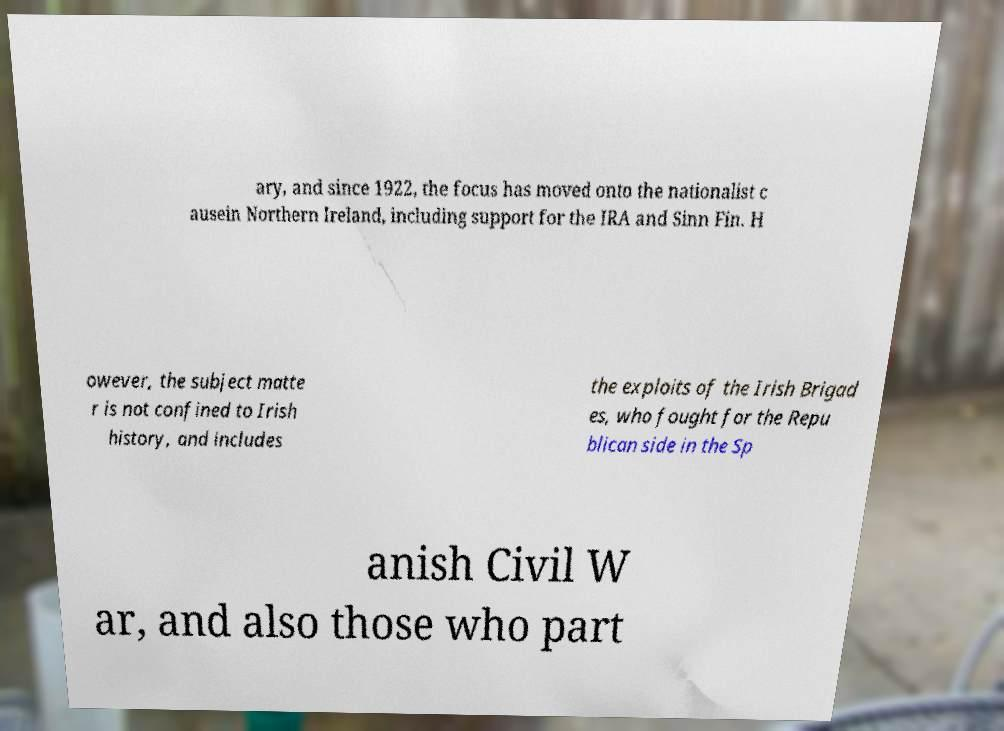Please identify and transcribe the text found in this image. ary, and since 1922, the focus has moved onto the nationalist c ausein Northern Ireland, including support for the IRA and Sinn Fin. H owever, the subject matte r is not confined to Irish history, and includes the exploits of the Irish Brigad es, who fought for the Repu blican side in the Sp anish Civil W ar, and also those who part 